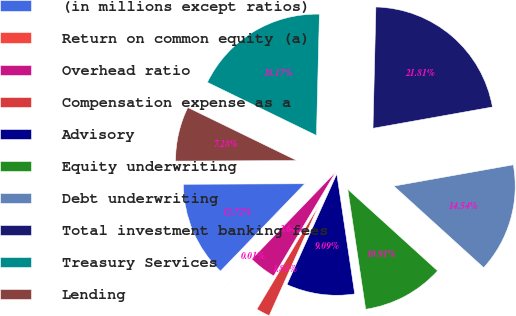<chart> <loc_0><loc_0><loc_500><loc_500><pie_chart><fcel>(in millions except ratios)<fcel>Return on common equity (a)<fcel>Overhead ratio<fcel>Compensation expense as a<fcel>Advisory<fcel>Equity underwriting<fcel>Debt underwriting<fcel>Total investment banking fees<fcel>Treasury Services<fcel>Lending<nl><fcel>12.72%<fcel>0.01%<fcel>3.64%<fcel>1.83%<fcel>9.09%<fcel>10.91%<fcel>14.54%<fcel>21.81%<fcel>18.17%<fcel>7.28%<nl></chart> 